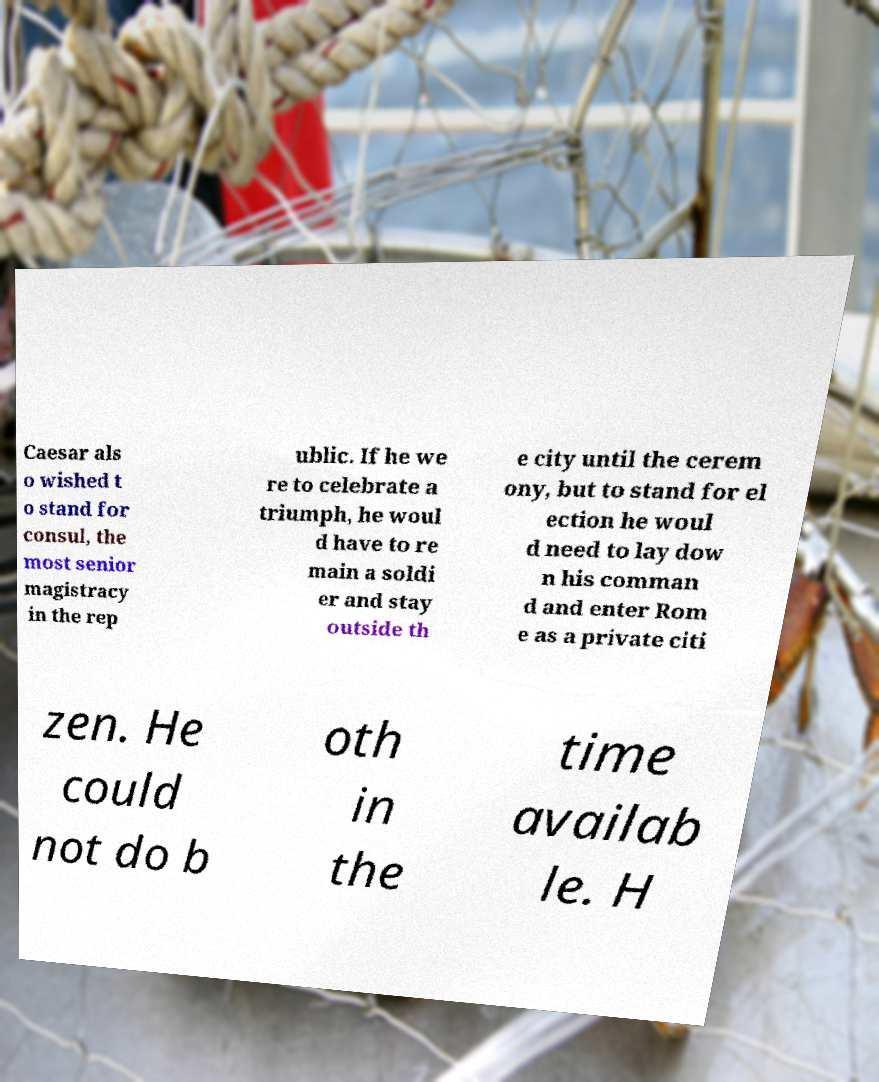What messages or text are displayed in this image? I need them in a readable, typed format. Caesar als o wished t o stand for consul, the most senior magistracy in the rep ublic. If he we re to celebrate a triumph, he woul d have to re main a soldi er and stay outside th e city until the cerem ony, but to stand for el ection he woul d need to lay dow n his comman d and enter Rom e as a private citi zen. He could not do b oth in the time availab le. H 